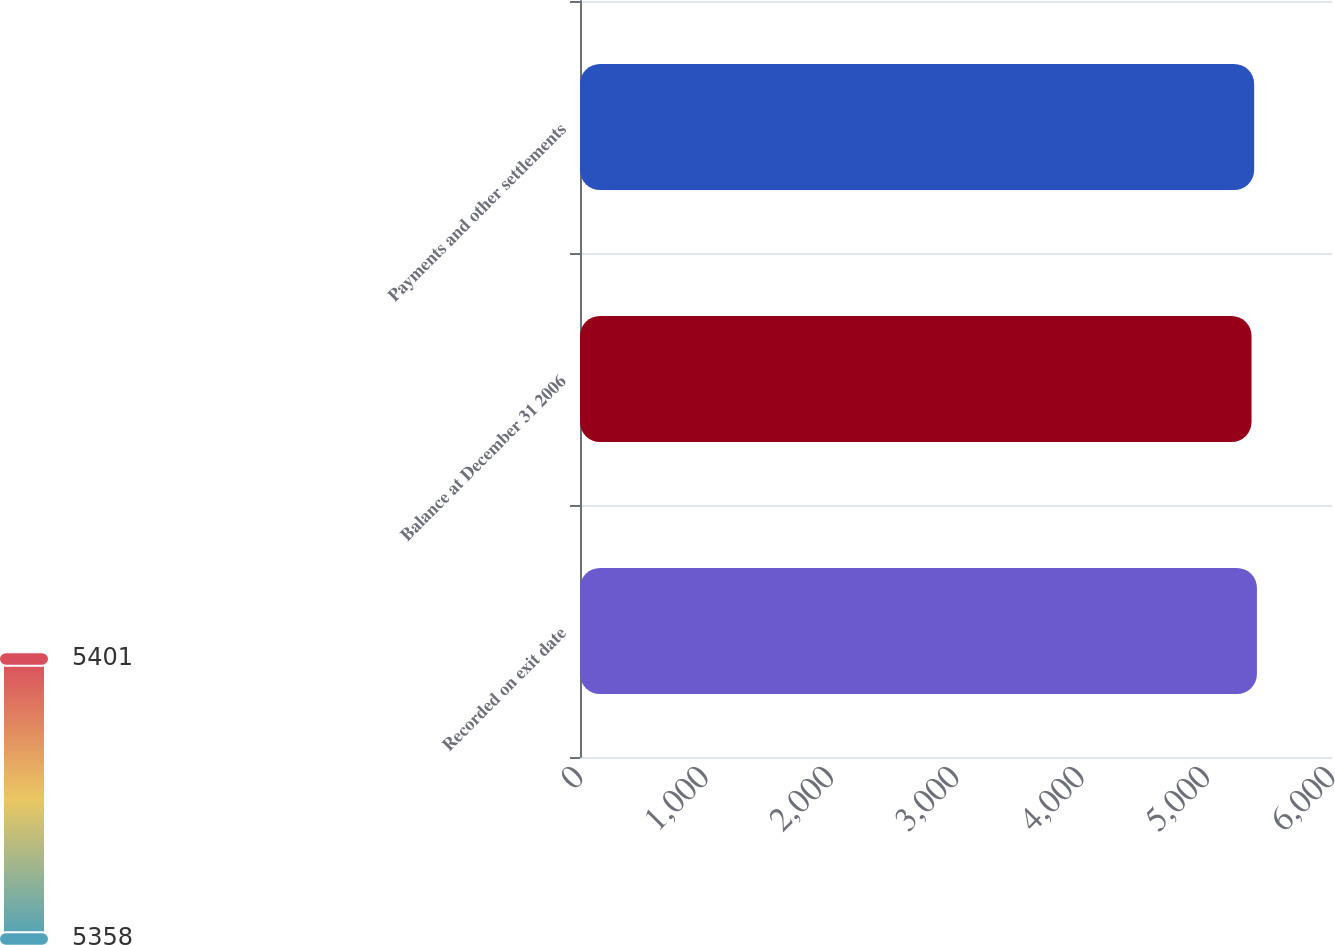Convert chart. <chart><loc_0><loc_0><loc_500><loc_500><bar_chart><fcel>Recorded on exit date<fcel>Balance at December 31 2006<fcel>Payments and other settlements<nl><fcel>5401<fcel>5358<fcel>5379<nl></chart> 